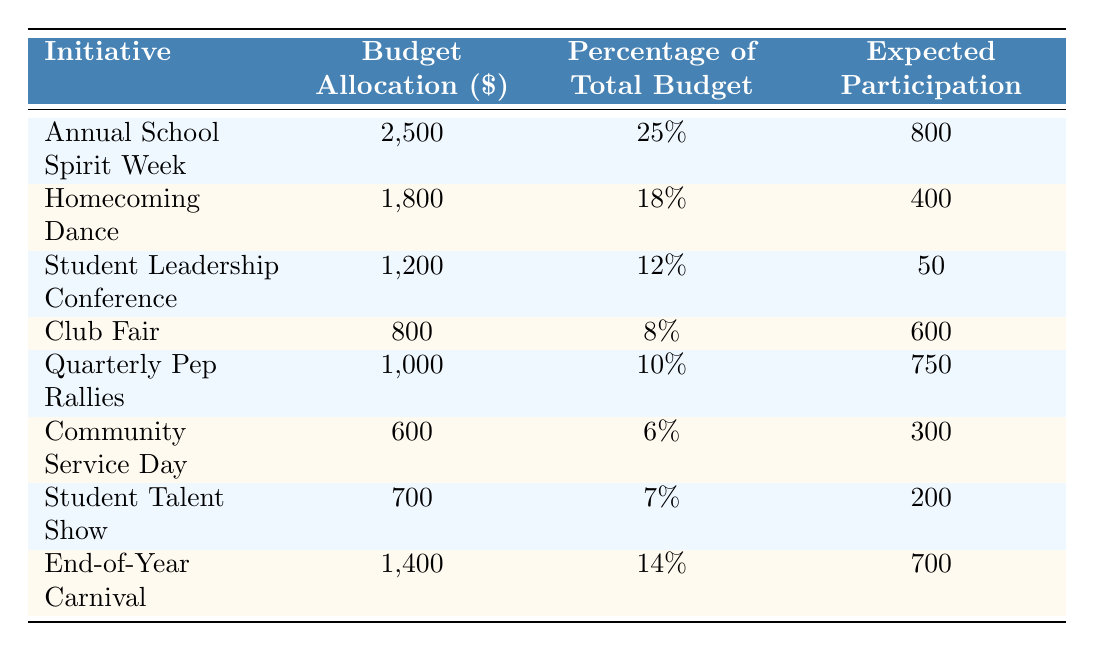What is the budget allocation for the Annual School Spirit Week? The budget allocation for the Annual School Spirit Week is stated directly in the table. It is 2,500 dollars.
Answer: 2,500 What percentage of the total budget is allocated for the Homecoming Dance? The table shows that the Homecoming Dance has a budget allocation of 18% of the total budget.
Answer: 18% What is the expected participation for the Student Leadership Conference? The expected participation for the Student Leadership Conference is specified in the table as 50 participants.
Answer: 50 Which initiative has the highest expected participation? By comparing the expected participation numbers in the table, the Annual School Spirit Week has the highest expected participation at 800.
Answer: Annual School Spirit Week What is the total budget allocation for all initiatives combined? Summing up all the budget allocations from the table: 2500 + 1800 + 1200 + 800 + 1000 + 600 + 700 + 1400 equals 10,500.
Answer: 10,500 Which initiatives have a budget allocation greater than $1,000? By reviewing the budget allocation amounts in the table, the initiatives with more than $1,000 are the Annual School Spirit Week (2,500), Homecoming Dance (1,800), and Quarterly Pep Rallies (1,000).
Answer: Annual School Spirit Week, Homecoming Dance, Quarterly Pep Rallies What is the average budget allocation for all the initiatives? To calculate the average, sum the budget allocations (10,500) and divide by the number of initiatives (8), which equals 1,312.50.
Answer: 1,312.50 Is the Community Service Day initiative budget allocation less than or equal to the budget for the Club Fair? Comparing the budget allocations in the table, Community Service Day has $600 and Club Fair has $800; therefore, $600 is less than $800.
Answer: Yes Which initiative has a budget allocation that is less than the average budget allocation? First, the average budget allocation is 1,312.50. Then, checking each initiative, Community Service Day (600), Student Talent Show (700), and Club Fair (800) have budget allocations that are less than the average.
Answer: Community Service Day, Student Talent Show, Club Fair What is the difference in expected participation between the End-of-Year Carnival and the Student Talent Show? The expected participation for the End-of-Year Carnival is 700, and for the Student Talent Show, it is 200. The difference is 700 - 200 = 500.
Answer: 500 